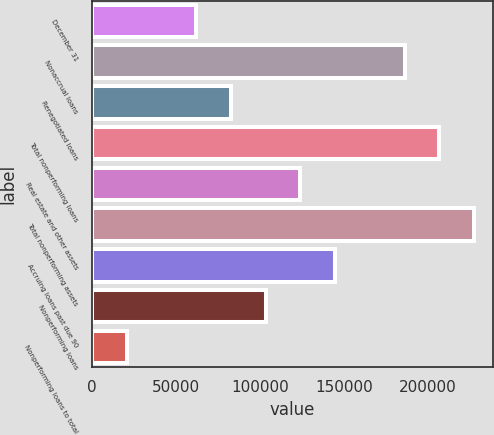Convert chart to OTSL. <chart><loc_0><loc_0><loc_500><loc_500><bar_chart><fcel>December 31<fcel>Nonaccrual loans<fcel>Renegotiated loans<fcel>Total nonperforming loans<fcel>Real estate and other assets<fcel>Total nonperforming assets<fcel>Accruing loans past due 90<fcel>Nonperforming loans<fcel>Nonperforming loans to total<nl><fcel>62058.1<fcel>186173<fcel>82743.9<fcel>206859<fcel>124116<fcel>227545<fcel>144801<fcel>103430<fcel>20686.4<nl></chart> 